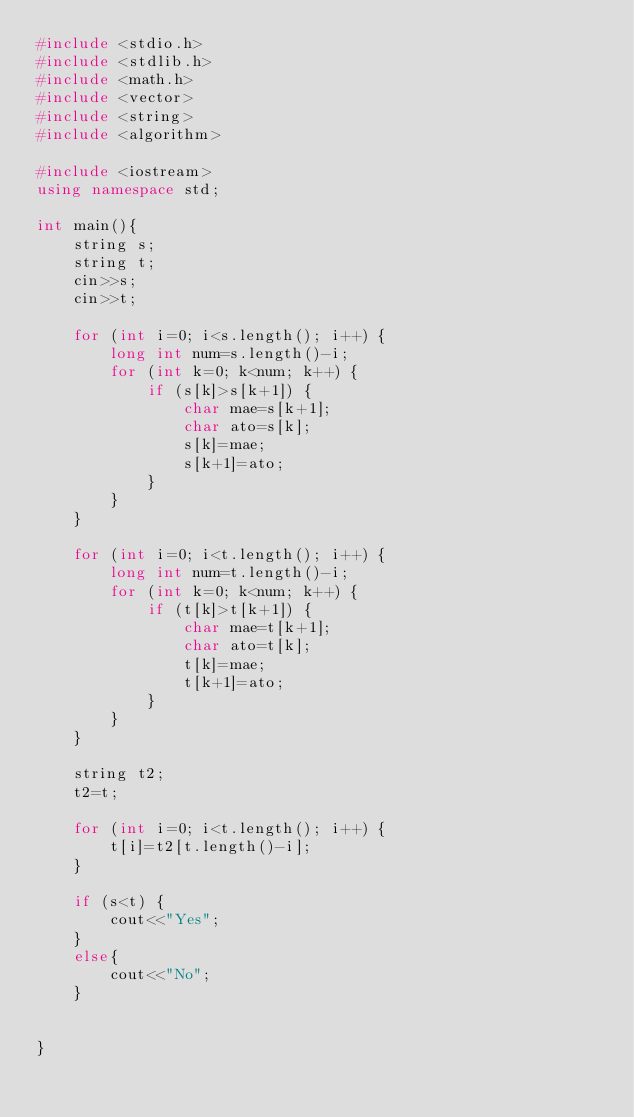<code> <loc_0><loc_0><loc_500><loc_500><_C++_>#include <stdio.h>
#include <stdlib.h>
#include <math.h>
#include <vector>
#include <string>
#include <algorithm>

#include <iostream>
using namespace std;

int main(){
    string s;
    string t;
    cin>>s;
    cin>>t;
    
    for (int i=0; i<s.length(); i++) {
        long int num=s.length()-i;
        for (int k=0; k<num; k++) {
            if (s[k]>s[k+1]) {
                char mae=s[k+1];
                char ato=s[k];
                s[k]=mae;
                s[k+1]=ato;
            }
        }
    }
    
    for (int i=0; i<t.length(); i++) {
        long int num=t.length()-i;
        for (int k=0; k<num; k++) {
            if (t[k]>t[k+1]) {
                char mae=t[k+1];
                char ato=t[k];
                t[k]=mae;
                t[k+1]=ato;
            }
        }
    }
    
    string t2;
    t2=t;
    
    for (int i=0; i<t.length(); i++) {
        t[i]=t2[t.length()-i];
    }
    
    if (s<t) {
        cout<<"Yes";
    }
    else{
        cout<<"No";
    }
    
    
}
</code> 